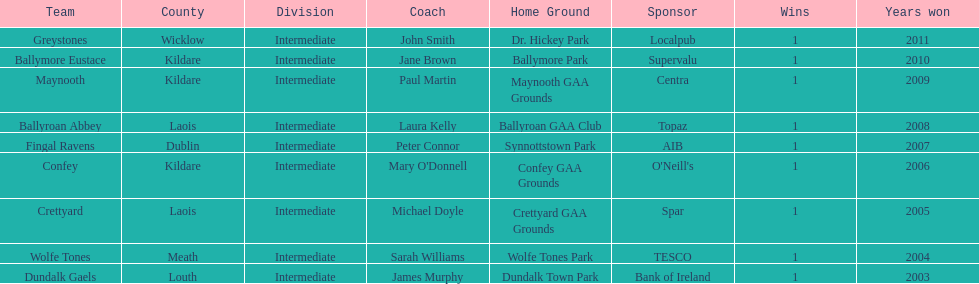Which team was the previous winner before ballyroan abbey in 2008? Fingal Ravens. 